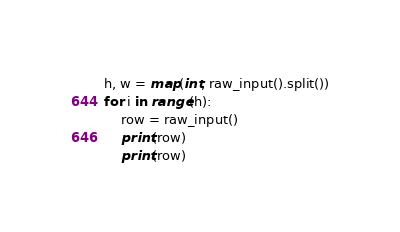<code> <loc_0><loc_0><loc_500><loc_500><_Python_>h, w = map(int, raw_input().split())
for i in range(h):
    row = raw_input()
    print(row)
    print(row)
</code> 